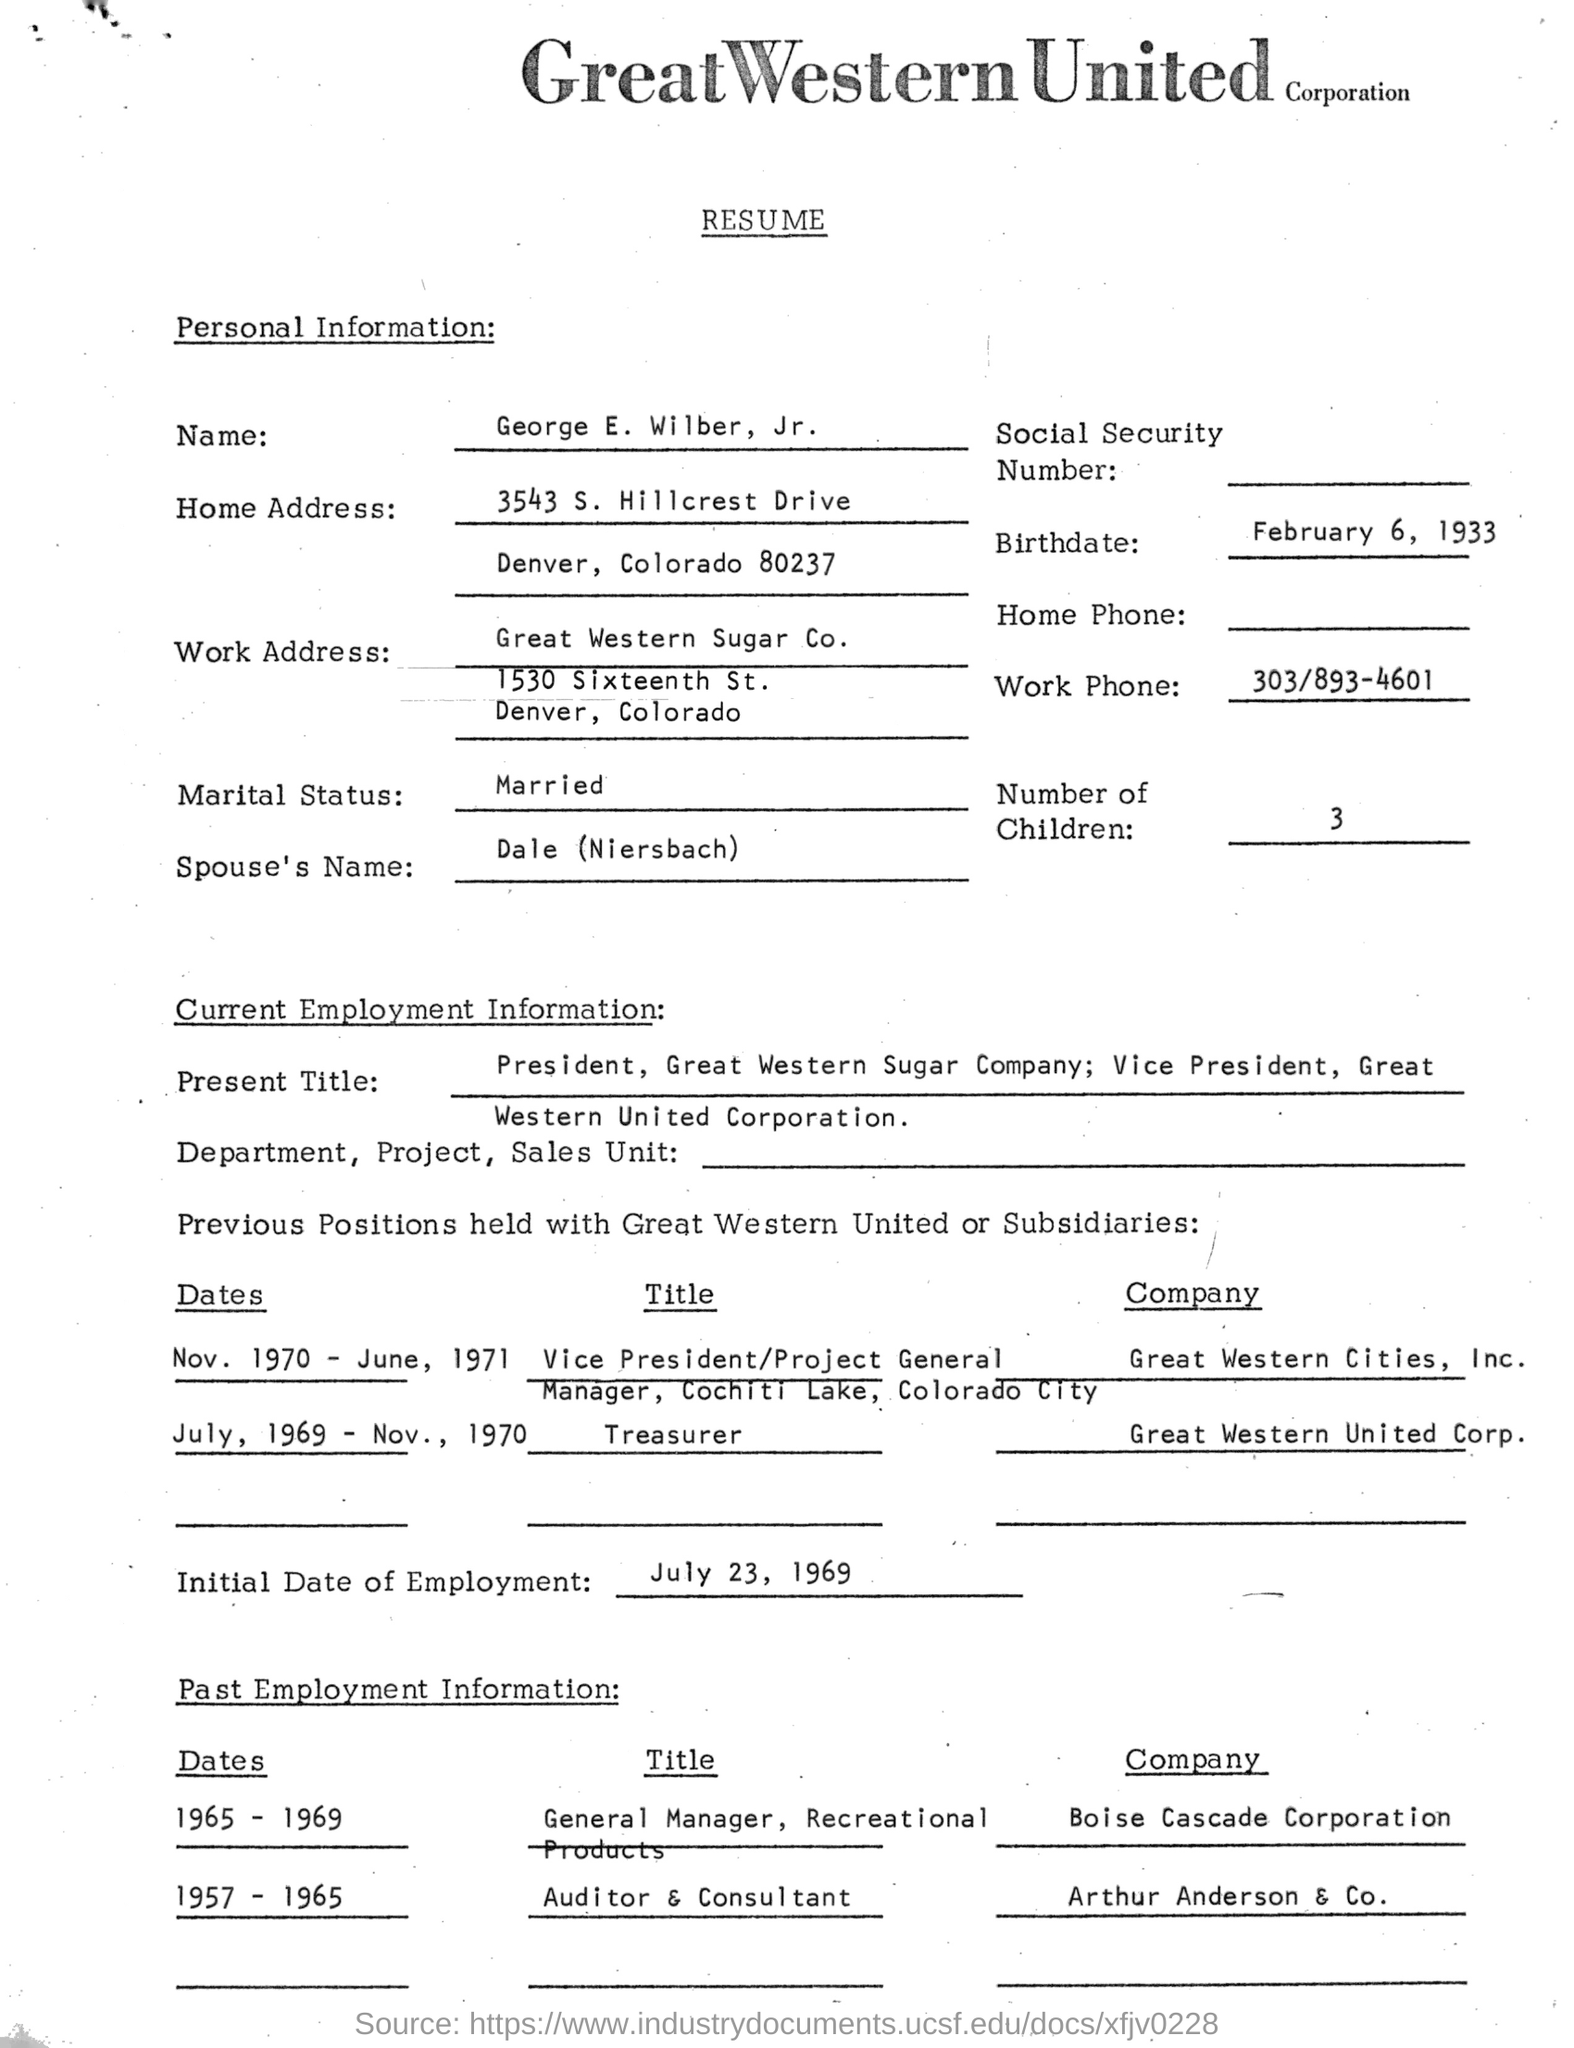Who's resume is provided here?
Give a very brief answer. George E. Wilber, Jr. What is the birthdate of George E. Wilber,  Jr.?
Your response must be concise. February 6, 1933. What is the Work Phone no mentioned here?
Keep it short and to the point. 303/893-4601. What is the Spouse's Name of George E. Wilber, Jr. ?
Your response must be concise. Dale (Niersbach). What is the Initial Date of Employment given?
Your answer should be compact. July 23, 1969. 